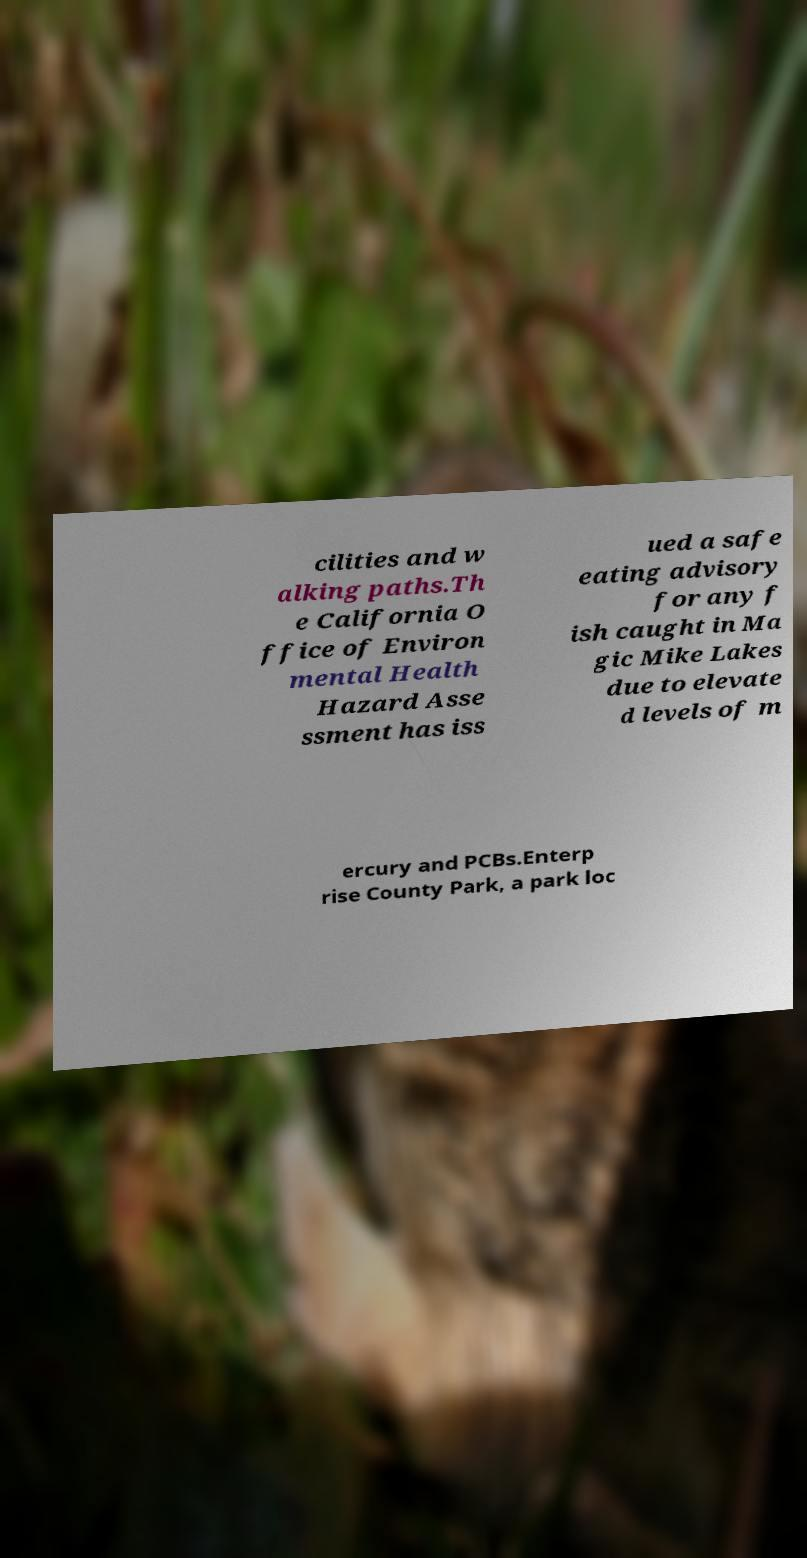Could you assist in decoding the text presented in this image and type it out clearly? cilities and w alking paths.Th e California O ffice of Environ mental Health Hazard Asse ssment has iss ued a safe eating advisory for any f ish caught in Ma gic Mike Lakes due to elevate d levels of m ercury and PCBs.Enterp rise County Park, a park loc 